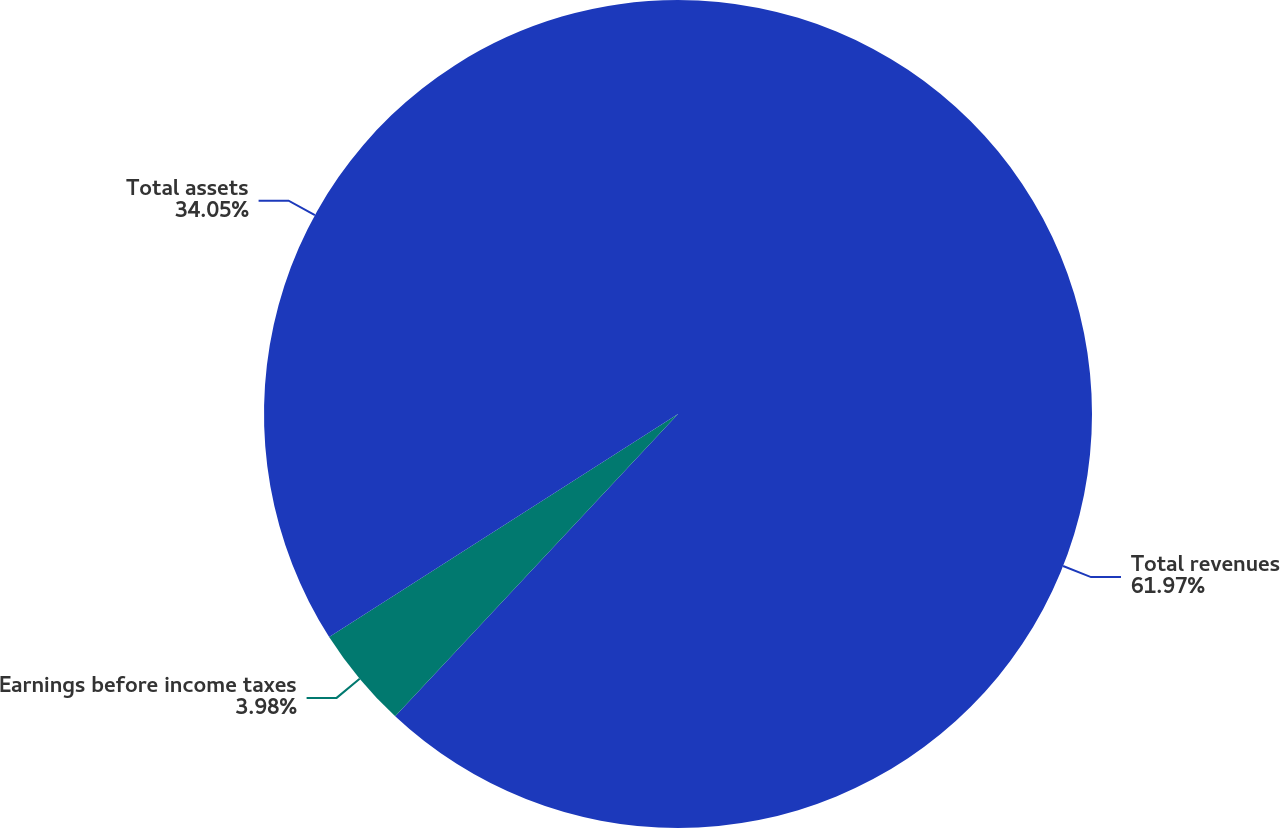Convert chart. <chart><loc_0><loc_0><loc_500><loc_500><pie_chart><fcel>Total revenues<fcel>Earnings before income taxes<fcel>Total assets<nl><fcel>61.97%<fcel>3.98%<fcel>34.05%<nl></chart> 